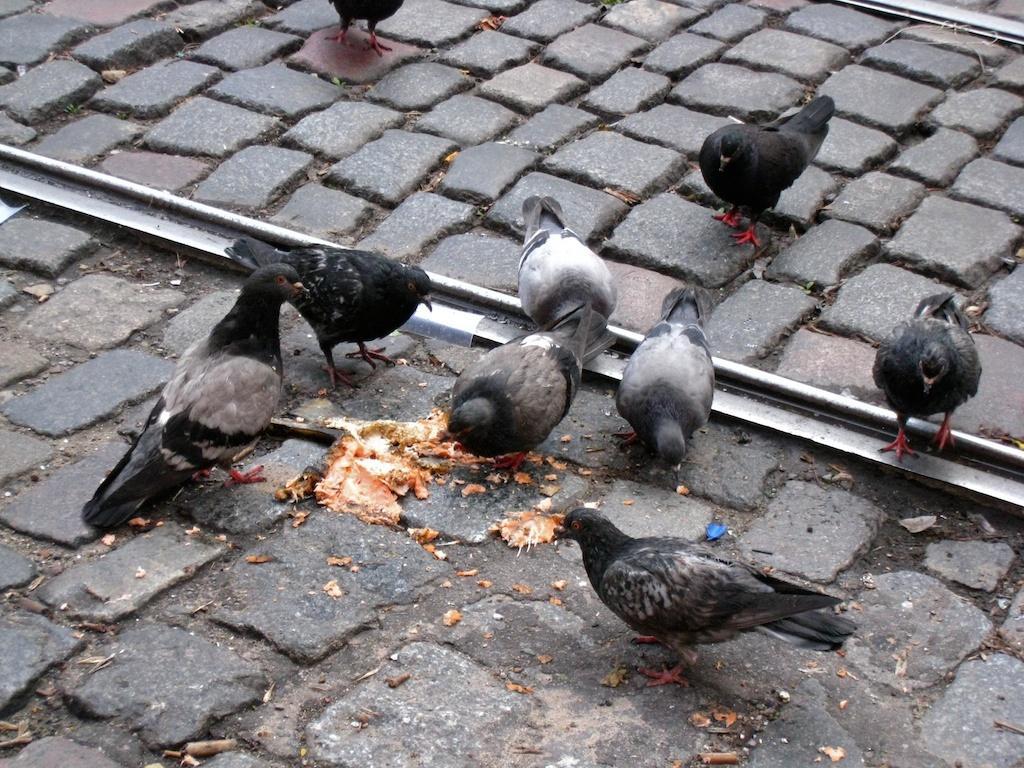Could you give a brief overview of what you see in this image? In the picture I can see pigeons on the road. Here I can see some food item on the road and I can see the railway track. 